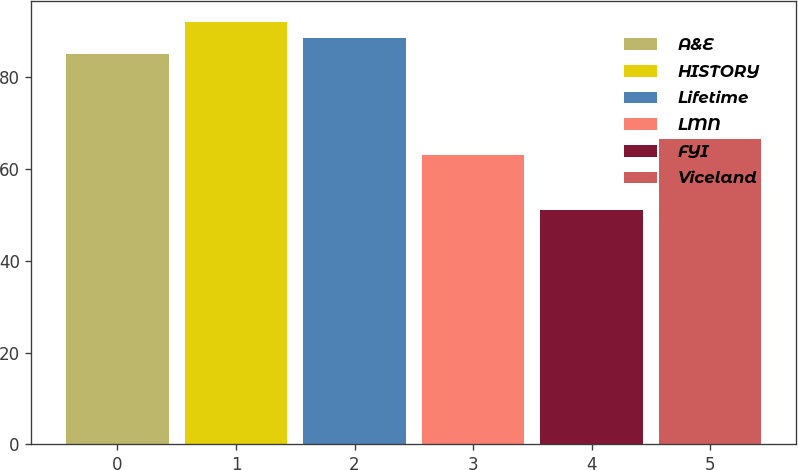Convert chart to OTSL. <chart><loc_0><loc_0><loc_500><loc_500><bar_chart><fcel>A&E<fcel>HISTORY<fcel>Lifetime<fcel>LMN<fcel>FYI<fcel>Viceland<nl><fcel>85<fcel>92<fcel>88.5<fcel>63<fcel>51<fcel>66.5<nl></chart> 